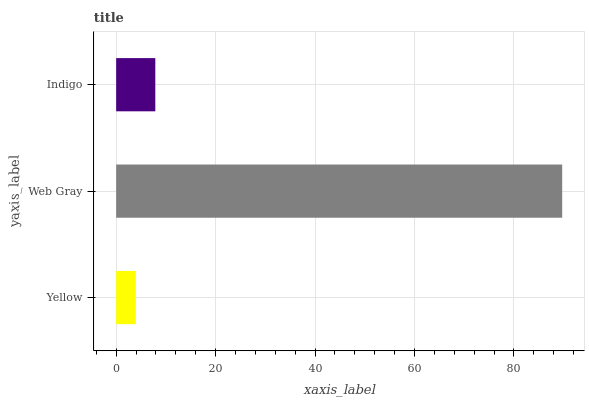Is Yellow the minimum?
Answer yes or no. Yes. Is Web Gray the maximum?
Answer yes or no. Yes. Is Indigo the minimum?
Answer yes or no. No. Is Indigo the maximum?
Answer yes or no. No. Is Web Gray greater than Indigo?
Answer yes or no. Yes. Is Indigo less than Web Gray?
Answer yes or no. Yes. Is Indigo greater than Web Gray?
Answer yes or no. No. Is Web Gray less than Indigo?
Answer yes or no. No. Is Indigo the high median?
Answer yes or no. Yes. Is Indigo the low median?
Answer yes or no. Yes. Is Web Gray the high median?
Answer yes or no. No. Is Yellow the low median?
Answer yes or no. No. 